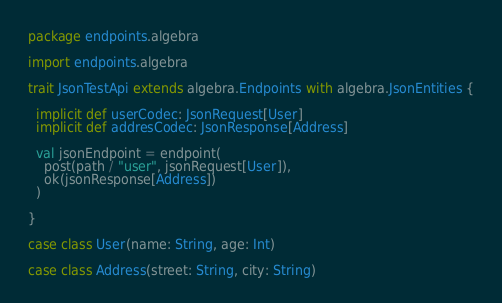<code> <loc_0><loc_0><loc_500><loc_500><_Scala_>package endpoints.algebra

import endpoints.algebra

trait JsonTestApi extends algebra.Endpoints with algebra.JsonEntities {

  implicit def userCodec: JsonRequest[User]
  implicit def addresCodec: JsonResponse[Address]

  val jsonEndpoint = endpoint(
    post(path / "user", jsonRequest[User]),
    ok(jsonResponse[Address])
  )

}

case class User(name: String, age: Int)

case class Address(street: String, city: String)
</code> 